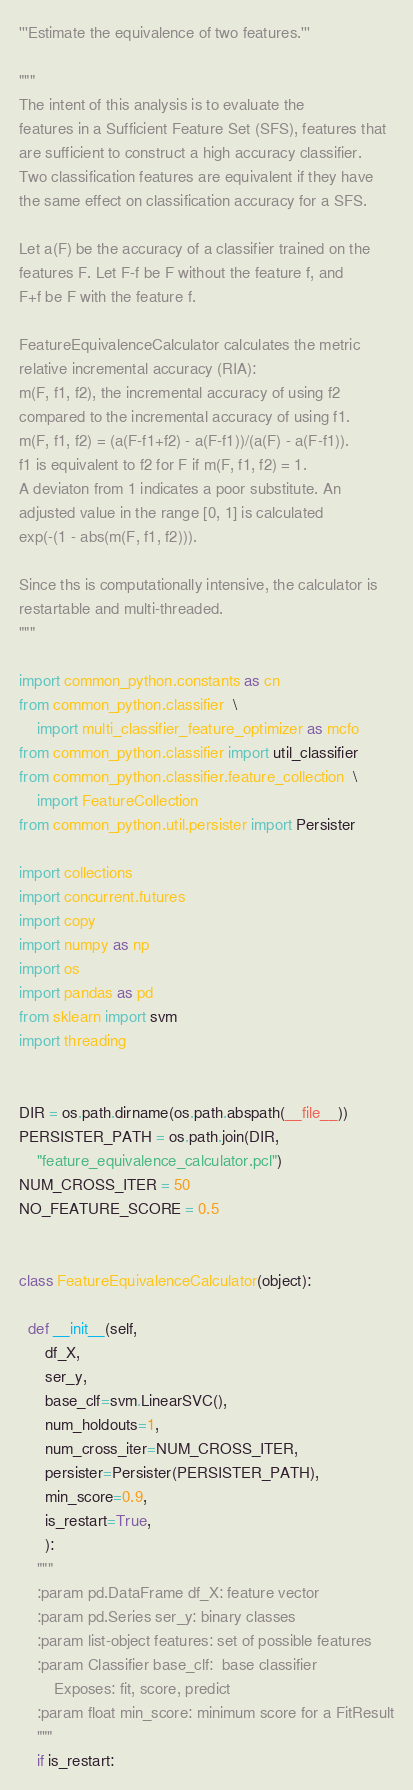Convert code to text. <code><loc_0><loc_0><loc_500><loc_500><_Python_>'''Estimate the equivalence of two features.'''

"""
The intent of this analysis is to evaluate the
features in a Sufficient Feature Set (SFS), features that
are sufficient to construct a high accuracy classifier.
Two classification features are equivalent if they have
the same effect on classification accuracy for a SFS.

Let a(F) be the accuracy of a classifier trained on the
features F. Let F-f be F without the feature f, and
F+f be F with the feature f.

FeatureEquivalenceCalculator calculates the metric
relative incremental accuracy (RIA):
m(F, f1, f2), the incremental accuracy of using f2
compared to the incremental accuracy of using f1.
m(F, f1, f2) = (a(F-f1+f2) - a(F-f1))/(a(F) - a(F-f1)).
f1 is equivalent to f2 for F if m(F, f1, f2) = 1.
A deviaton from 1 indicates a poor substitute. An
adjusted value in the range [0, 1] is calculated
exp(-(1 - abs(m(F, f1, f2))).

Since ths is computationally intensive, the calculator is
restartable and multi-threaded.
"""

import common_python.constants as cn
from common_python.classifier  \
    import multi_classifier_feature_optimizer as mcfo
from common_python.classifier import util_classifier
from common_python.classifier.feature_collection  \
    import FeatureCollection
from common_python.util.persister import Persister

import collections
import concurrent.futures
import copy
import numpy as np
import os
import pandas as pd
from sklearn import svm
import threading


DIR = os.path.dirname(os.path.abspath(__file__))
PERSISTER_PATH = os.path.join(DIR,
    "feature_equivalence_calculator.pcl")
NUM_CROSS_ITER = 50
NO_FEATURE_SCORE = 0.5


class FeatureEquivalenceCalculator(object):

  def __init__(self,
      df_X,
      ser_y,
      base_clf=svm.LinearSVC(),
      num_holdouts=1,
      num_cross_iter=NUM_CROSS_ITER,
      persister=Persister(PERSISTER_PATH),
      min_score=0.9,
      is_restart=True,
      ):
    """
    :param pd.DataFrame df_X: feature vector
    :param pd.Series ser_y: binary classes
    :param list-object features: set of possible features
    :param Classifier base_clf:  base classifier
        Exposes: fit, score, predict
    :param float min_score: minimum score for a FitResult
    """
    if is_restart:</code> 